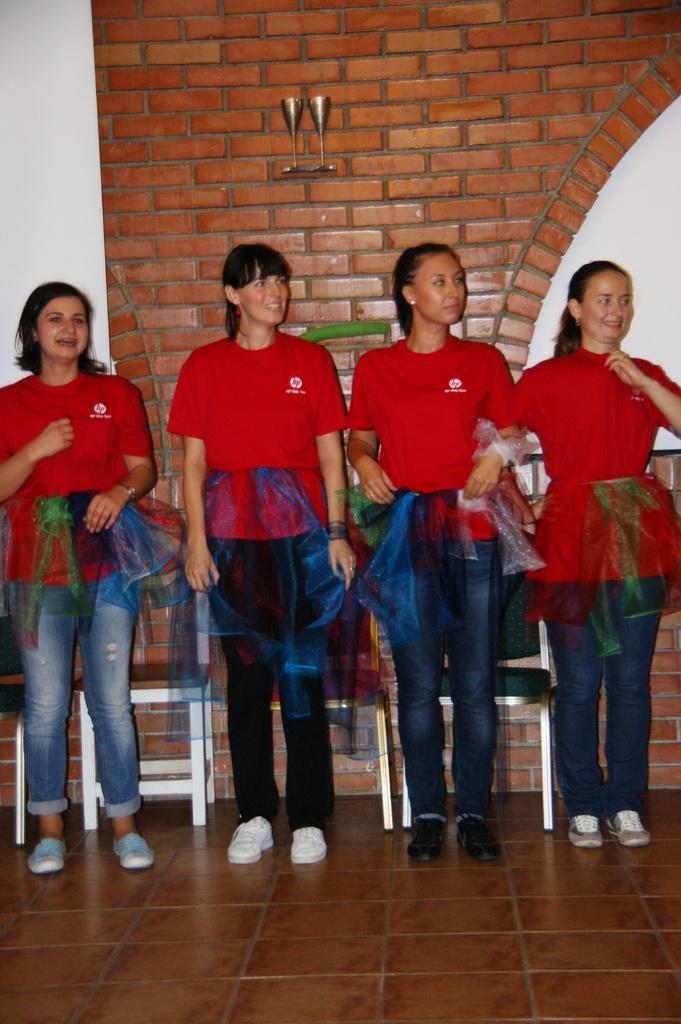In one or two sentences, can you explain what this image depicts? In this image I can see four women wearing red , blue and black colored dress are standing and I can see few chairs behind them. In the background I can see the wall which is brown and white in color and few objects to the wall. 